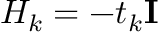Convert formula to latex. <formula><loc_0><loc_0><loc_500><loc_500>H _ { k } = - t _ { k } I</formula> 